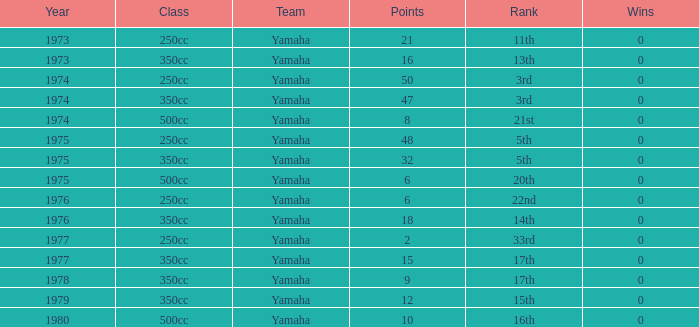For the 500cc class, what is the greatest number of wins when the points are under 6? None. 